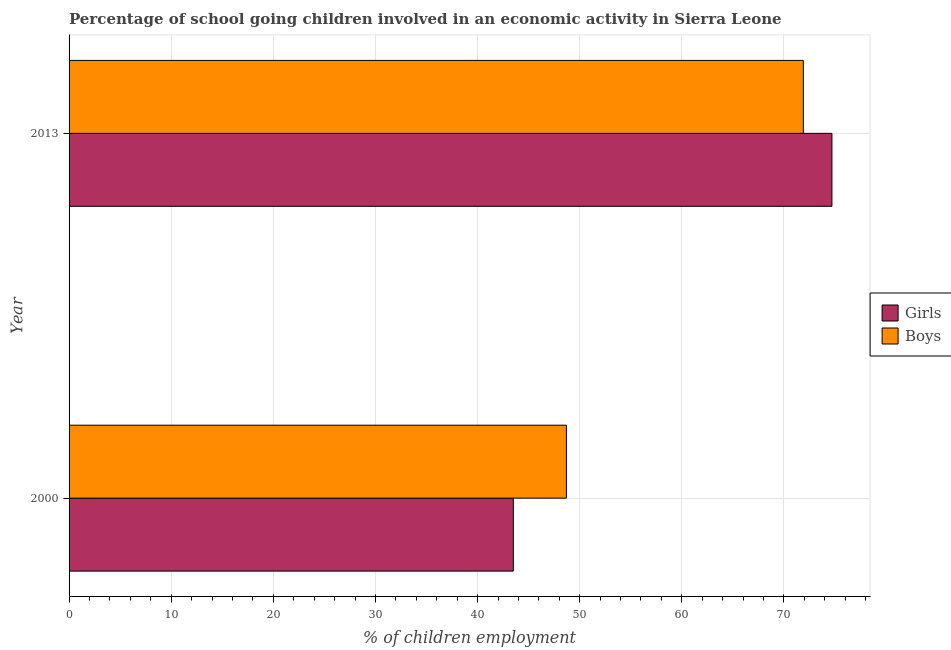How many different coloured bars are there?
Offer a terse response. 2. How many groups of bars are there?
Keep it short and to the point. 2. Are the number of bars per tick equal to the number of legend labels?
Your answer should be compact. Yes. Are the number of bars on each tick of the Y-axis equal?
Keep it short and to the point. Yes. How many bars are there on the 2nd tick from the bottom?
Offer a very short reply. 2. What is the label of the 1st group of bars from the top?
Give a very brief answer. 2013. In how many cases, is the number of bars for a given year not equal to the number of legend labels?
Your answer should be very brief. 0. What is the percentage of school going girls in 2000?
Make the answer very short. 43.5. Across all years, what is the maximum percentage of school going boys?
Your response must be concise. 71.9. Across all years, what is the minimum percentage of school going boys?
Offer a terse response. 48.7. In which year was the percentage of school going boys maximum?
Offer a very short reply. 2013. In which year was the percentage of school going girls minimum?
Offer a very short reply. 2000. What is the total percentage of school going boys in the graph?
Your answer should be compact. 120.6. What is the difference between the percentage of school going girls in 2000 and that in 2013?
Your answer should be compact. -31.2. What is the difference between the percentage of school going boys in 2000 and the percentage of school going girls in 2013?
Ensure brevity in your answer.  -26. What is the average percentage of school going boys per year?
Your answer should be compact. 60.3. What is the ratio of the percentage of school going girls in 2000 to that in 2013?
Your answer should be very brief. 0.58. Is the percentage of school going girls in 2000 less than that in 2013?
Your answer should be very brief. Yes. Is the difference between the percentage of school going boys in 2000 and 2013 greater than the difference between the percentage of school going girls in 2000 and 2013?
Your answer should be compact. Yes. What does the 2nd bar from the top in 2013 represents?
Your answer should be very brief. Girls. What does the 1st bar from the bottom in 2000 represents?
Your answer should be very brief. Girls. How many bars are there?
Offer a very short reply. 4. How many years are there in the graph?
Offer a very short reply. 2. Are the values on the major ticks of X-axis written in scientific E-notation?
Your answer should be compact. No. Does the graph contain any zero values?
Provide a short and direct response. No. How many legend labels are there?
Your answer should be compact. 2. How are the legend labels stacked?
Give a very brief answer. Vertical. What is the title of the graph?
Your answer should be compact. Percentage of school going children involved in an economic activity in Sierra Leone. What is the label or title of the X-axis?
Keep it short and to the point. % of children employment. What is the label or title of the Y-axis?
Offer a very short reply. Year. What is the % of children employment in Girls in 2000?
Make the answer very short. 43.5. What is the % of children employment in Boys in 2000?
Offer a terse response. 48.7. What is the % of children employment of Girls in 2013?
Keep it short and to the point. 74.7. What is the % of children employment in Boys in 2013?
Your answer should be compact. 71.9. Across all years, what is the maximum % of children employment of Girls?
Offer a terse response. 74.7. Across all years, what is the maximum % of children employment of Boys?
Offer a very short reply. 71.9. Across all years, what is the minimum % of children employment in Girls?
Offer a terse response. 43.5. Across all years, what is the minimum % of children employment in Boys?
Give a very brief answer. 48.7. What is the total % of children employment of Girls in the graph?
Offer a very short reply. 118.2. What is the total % of children employment of Boys in the graph?
Your answer should be compact. 120.6. What is the difference between the % of children employment in Girls in 2000 and that in 2013?
Your response must be concise. -31.2. What is the difference between the % of children employment of Boys in 2000 and that in 2013?
Give a very brief answer. -23.2. What is the difference between the % of children employment of Girls in 2000 and the % of children employment of Boys in 2013?
Your response must be concise. -28.4. What is the average % of children employment in Girls per year?
Provide a short and direct response. 59.1. What is the average % of children employment in Boys per year?
Provide a succinct answer. 60.3. In the year 2000, what is the difference between the % of children employment in Girls and % of children employment in Boys?
Offer a very short reply. -5.2. In the year 2013, what is the difference between the % of children employment in Girls and % of children employment in Boys?
Your answer should be compact. 2.8. What is the ratio of the % of children employment of Girls in 2000 to that in 2013?
Give a very brief answer. 0.58. What is the ratio of the % of children employment of Boys in 2000 to that in 2013?
Your answer should be compact. 0.68. What is the difference between the highest and the second highest % of children employment of Girls?
Keep it short and to the point. 31.2. What is the difference between the highest and the second highest % of children employment of Boys?
Your answer should be compact. 23.2. What is the difference between the highest and the lowest % of children employment in Girls?
Your answer should be compact. 31.2. What is the difference between the highest and the lowest % of children employment in Boys?
Your answer should be compact. 23.2. 